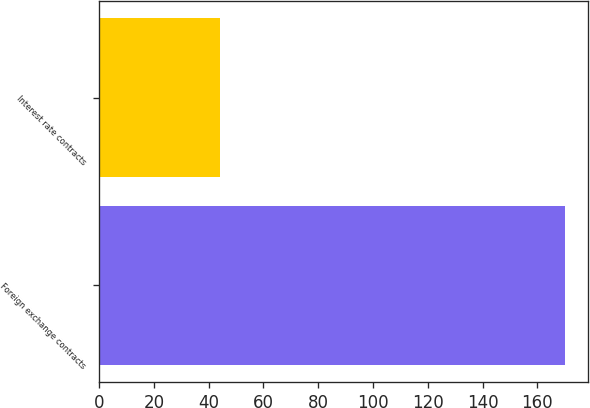<chart> <loc_0><loc_0><loc_500><loc_500><bar_chart><fcel>Foreign exchange contracts<fcel>Interest rate contracts<nl><fcel>170<fcel>44<nl></chart> 